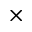<formula> <loc_0><loc_0><loc_500><loc_500>\times</formula> 